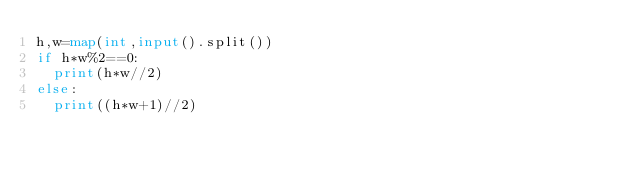<code> <loc_0><loc_0><loc_500><loc_500><_Python_>h,w=map(int,input().split())
if h*w%2==0:
  print(h*w//2)
else:
  print((h*w+1)//2)</code> 